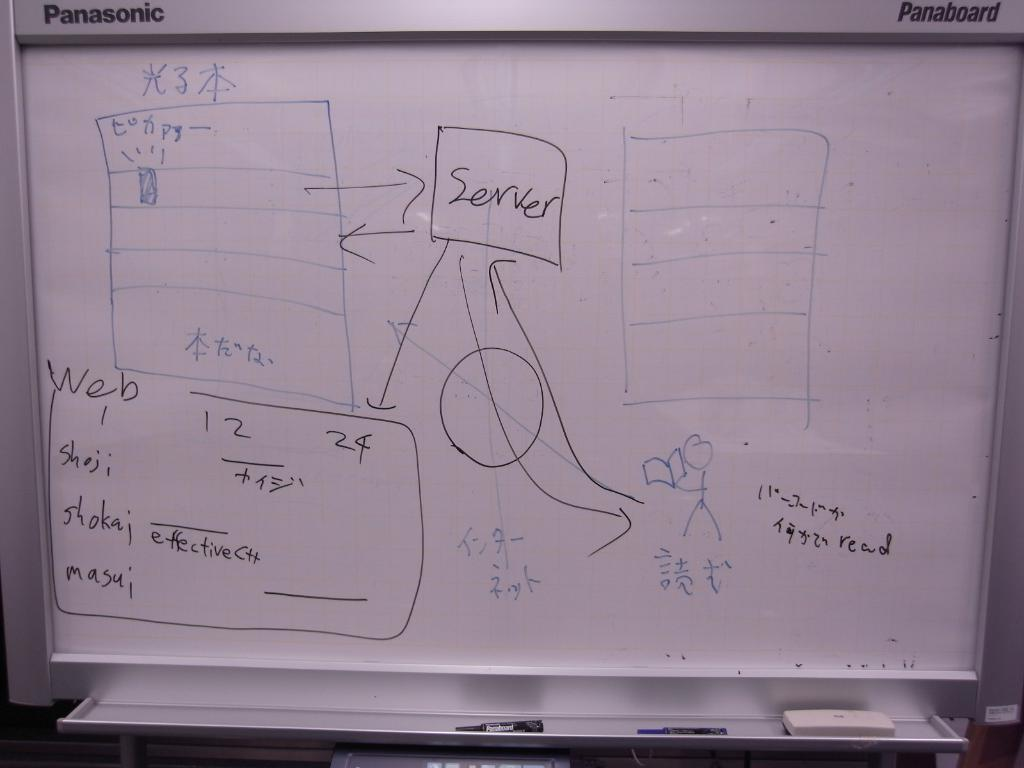<image>
Provide a brief description of the given image. Whiteboard which says Server in the middle of it. 